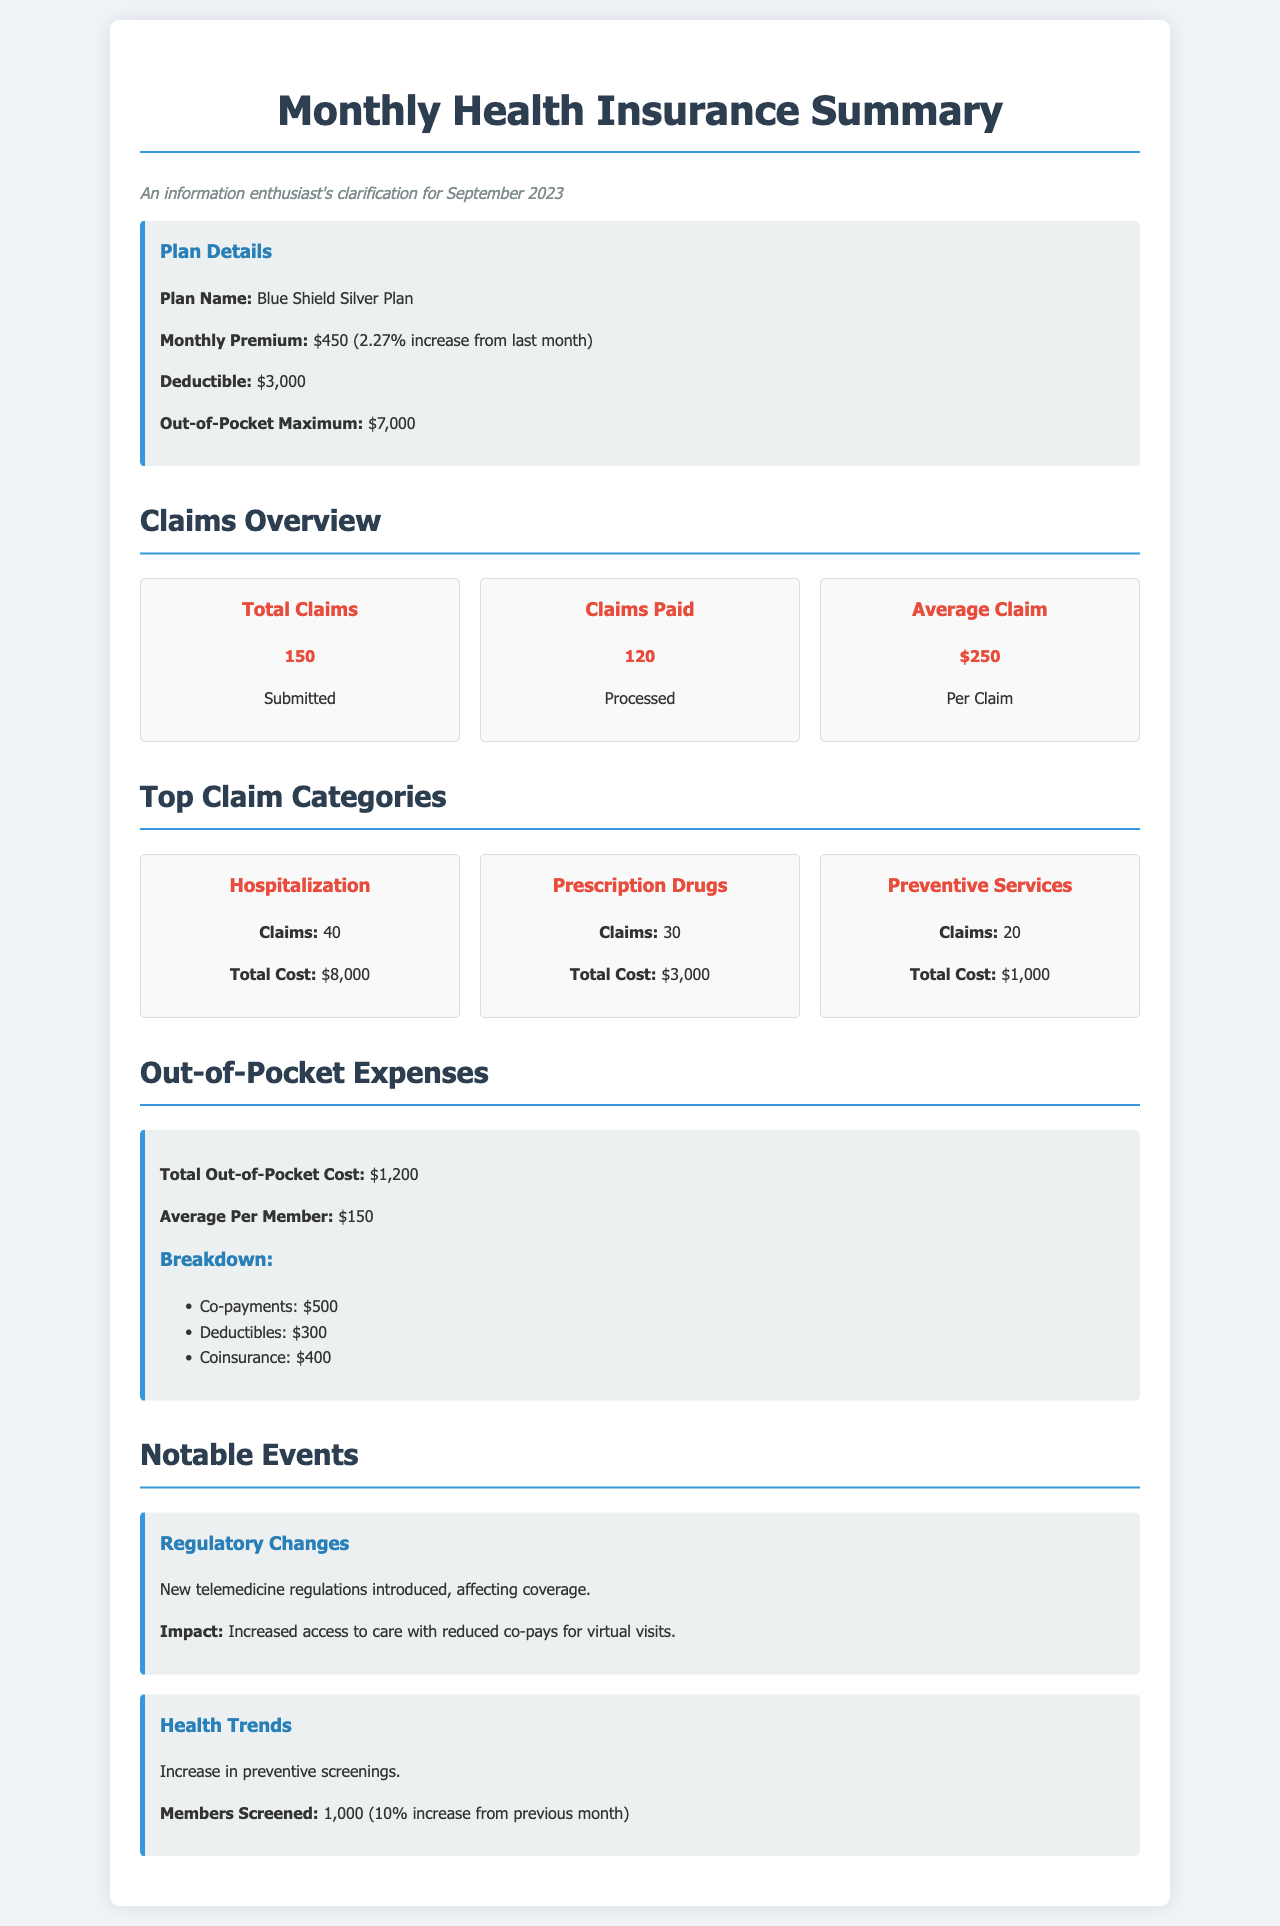what is the monthly premium? The monthly premium for the Blue Shield Silver Plan is stated directly in the document.
Answer: $450 how many claims were submitted? The total number of submitted claims is provided in the claims overview section.
Answer: 150 what is the average claim amount? The average claim amount is clearly indicated within the claims overview.
Answer: $250 what was the increase in the monthly premium from last month? The change in the monthly premium is mentioned directly after the premium value.
Answer: 2.27% how many members were screened for preventive services? The number of members screened is mentioned in the health trends section.
Answer: 1,000 what is the total out-of-pocket cost? The total out-of-pocket expense is summarized under the out-of-pocket expenses section.
Answer: $1,200 what is the deductible amount? The deductible amount for the health plan is provided in the plan details section.
Answer: $3,000 which claim category had the highest total cost? The claim category with the highest total cost can be identified by comparing the total costs from the top claim categories section.
Answer: Hospitalization what regulatory changes were introduced? The specific notable event regarding regulatory changes is detailed in the notable events section.
Answer: New telemedicine regulations 